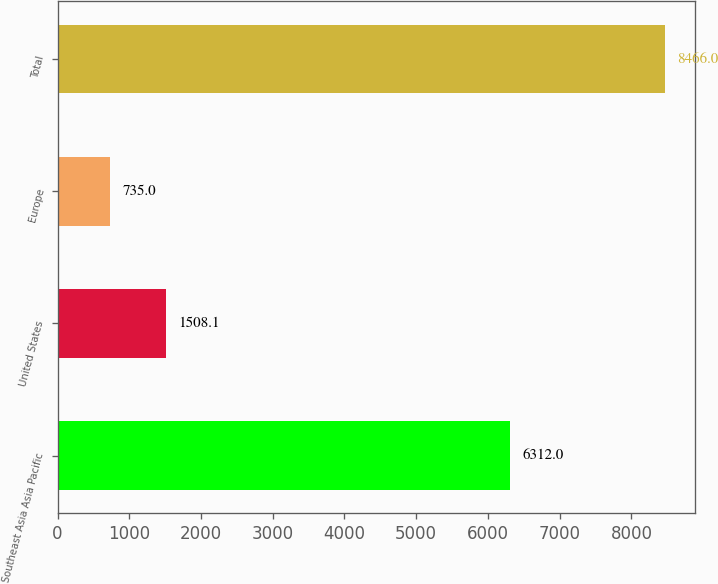Convert chart. <chart><loc_0><loc_0><loc_500><loc_500><bar_chart><fcel>Southeast Asia Asia Pacific<fcel>United States<fcel>Europe<fcel>Total<nl><fcel>6312<fcel>1508.1<fcel>735<fcel>8466<nl></chart> 